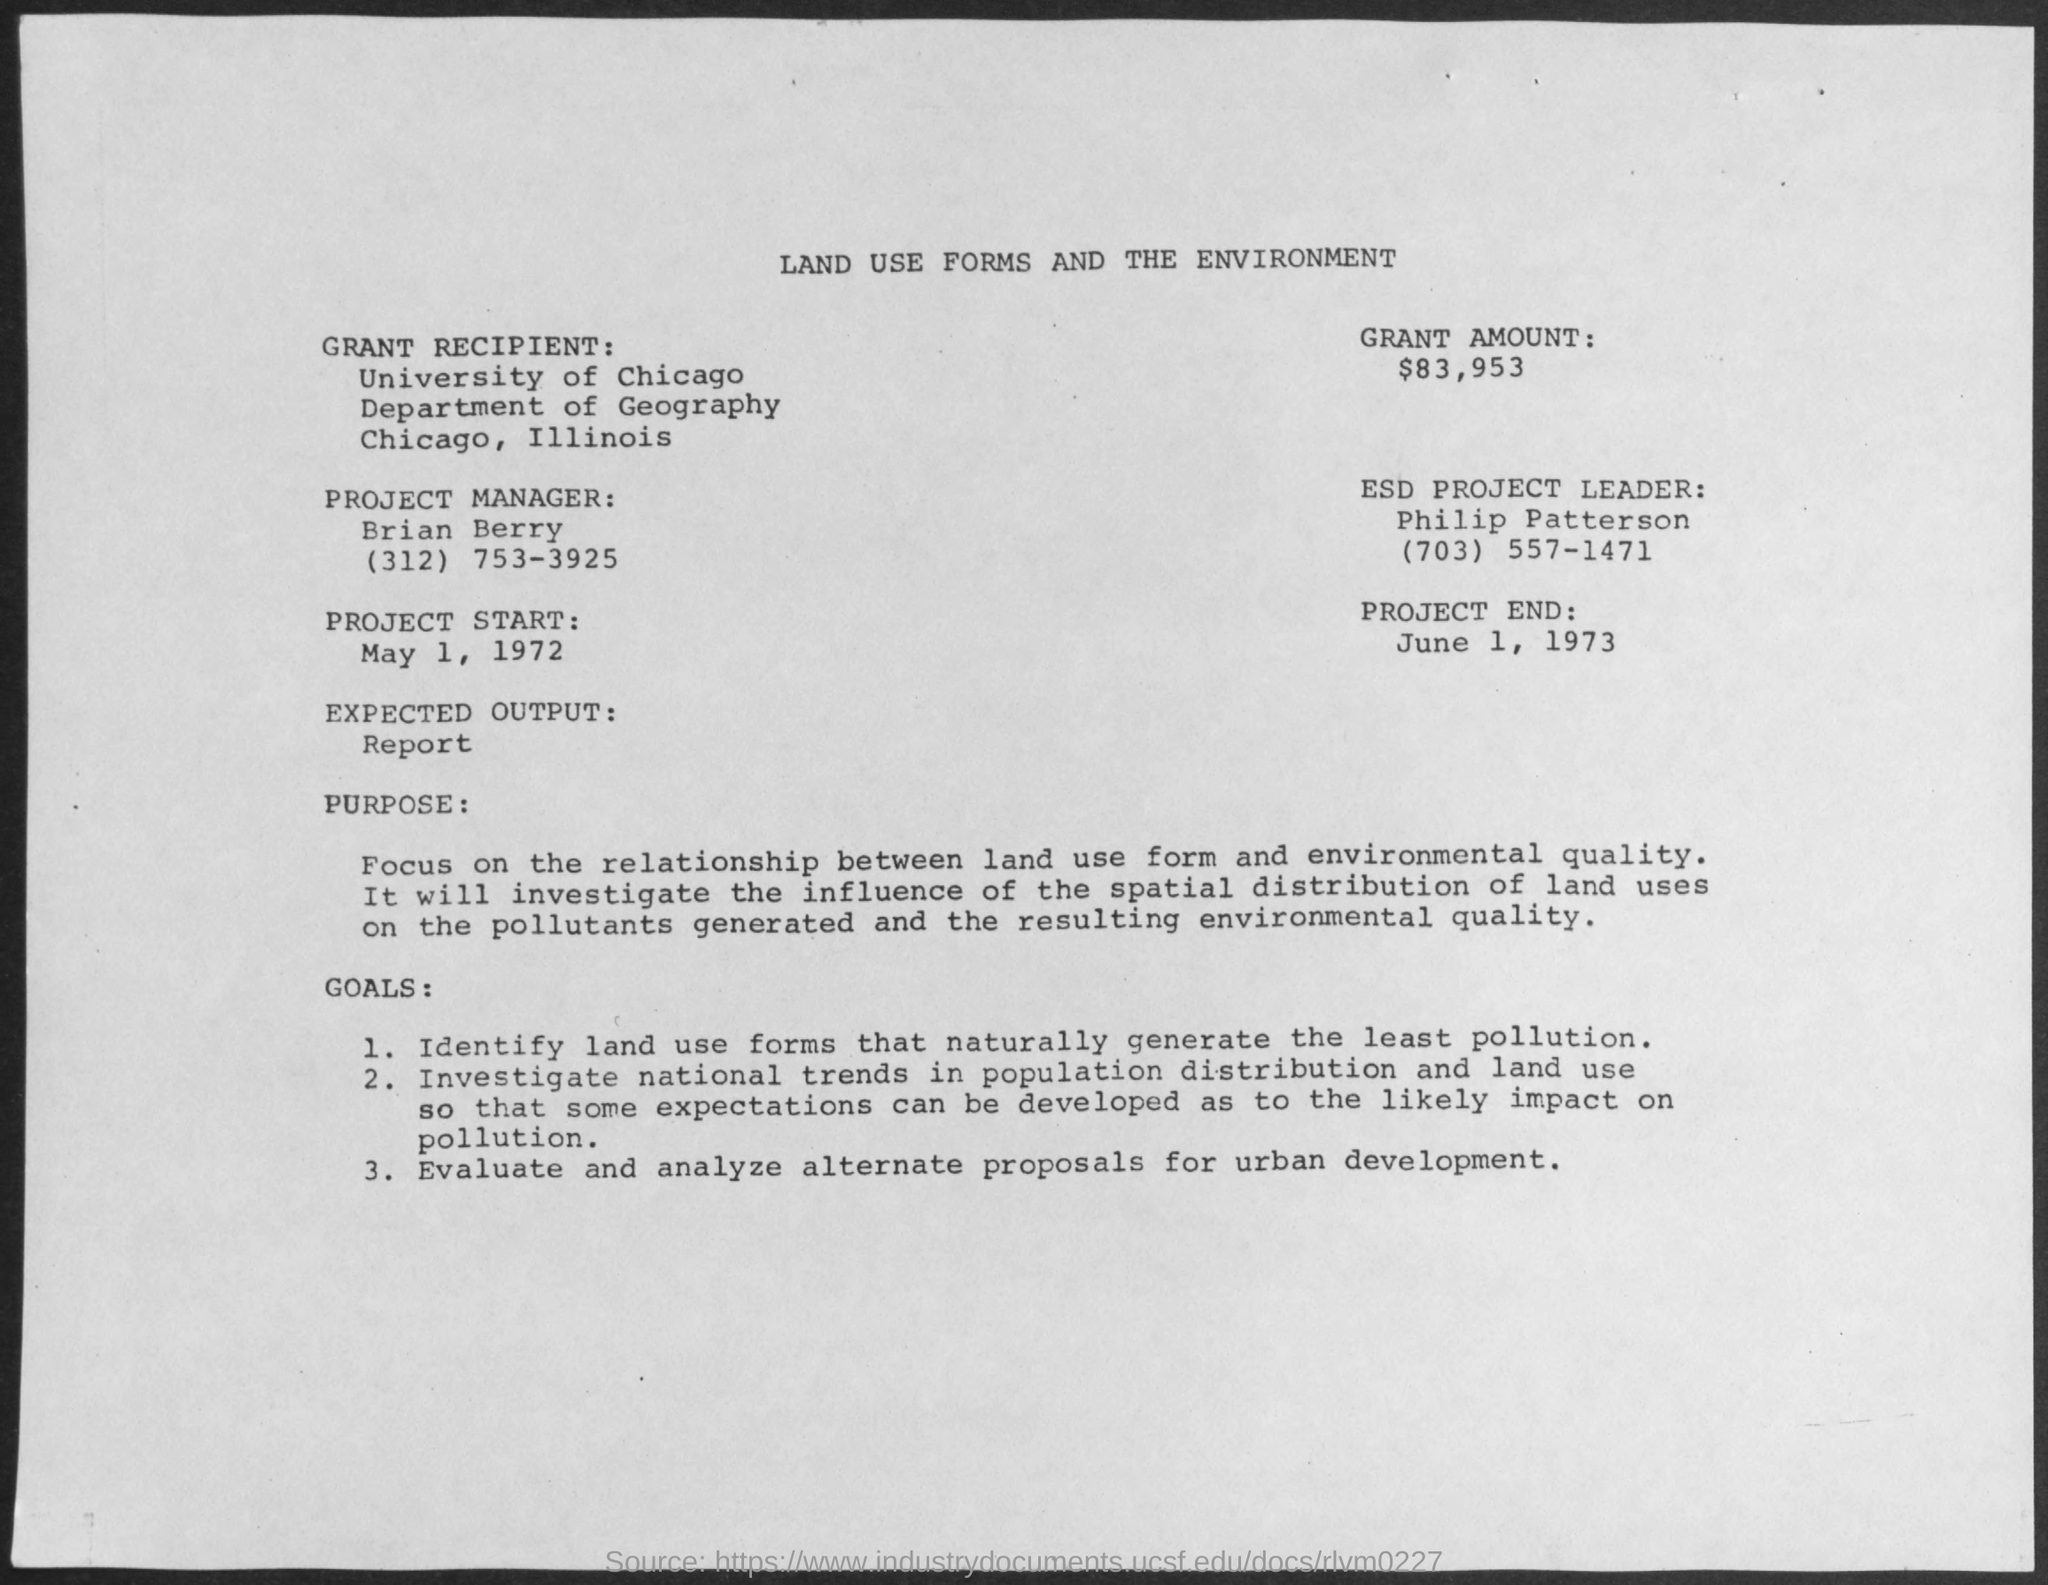Give some essential details in this illustration. The expected output in the given document is a report. The contact number for Philip Patterson is (703) 557-1471. The ESD Project Leader as per the document is Philip Patterson. The grant amount mentioned in the document is $83,953. The University of Chicago is the grant recipient mentioned in the document. 